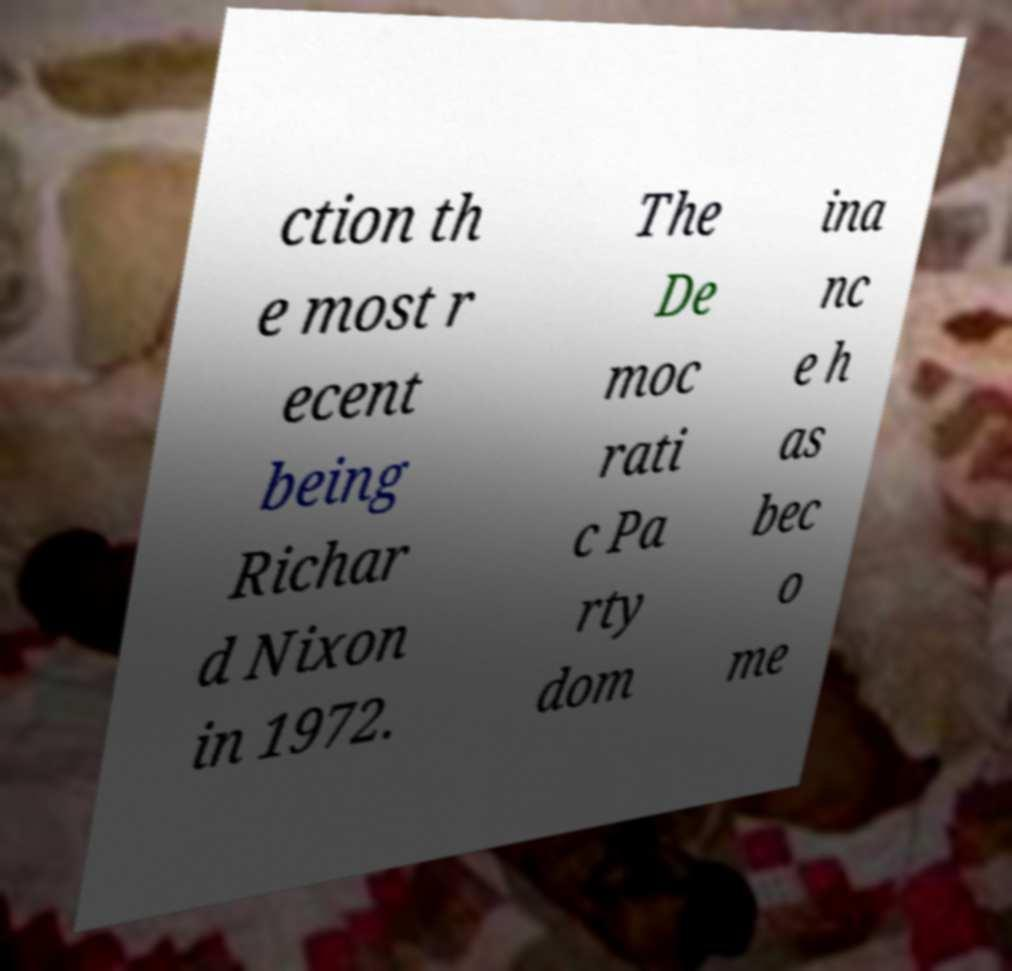What messages or text are displayed in this image? I need them in a readable, typed format. ction th e most r ecent being Richar d Nixon in 1972. The De moc rati c Pa rty dom ina nc e h as bec o me 